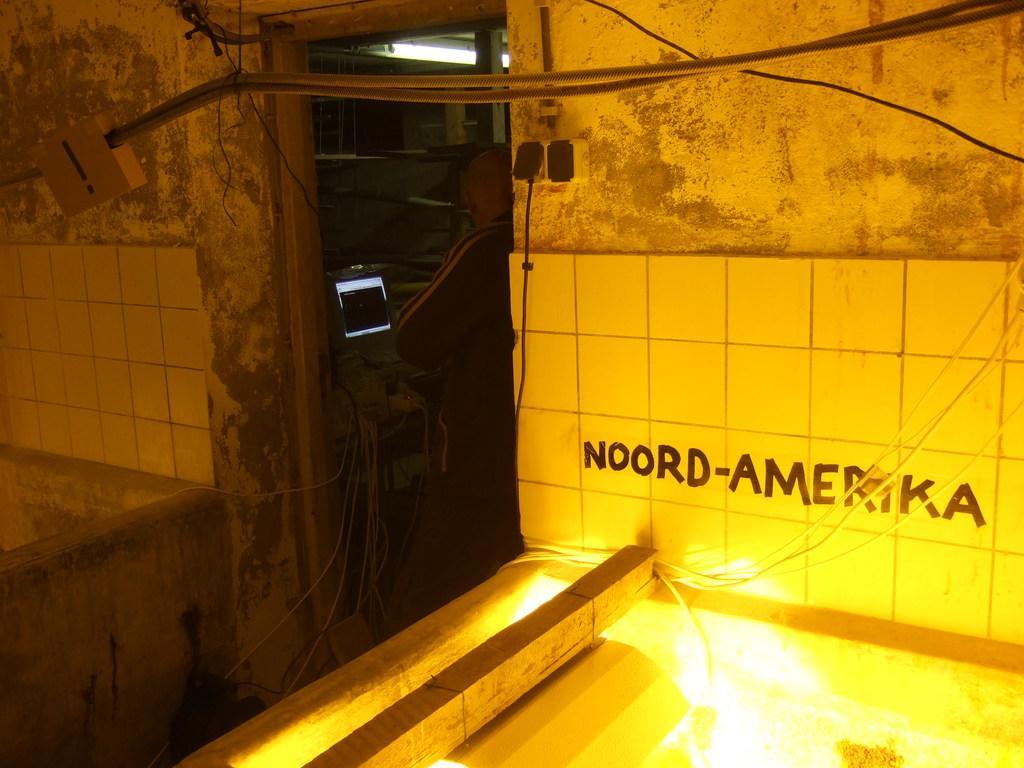Describe this image in one or two sentences. In the center of the image there is a computer and person standing at the door. On the right side of the image there is a wire, wall and lights. 